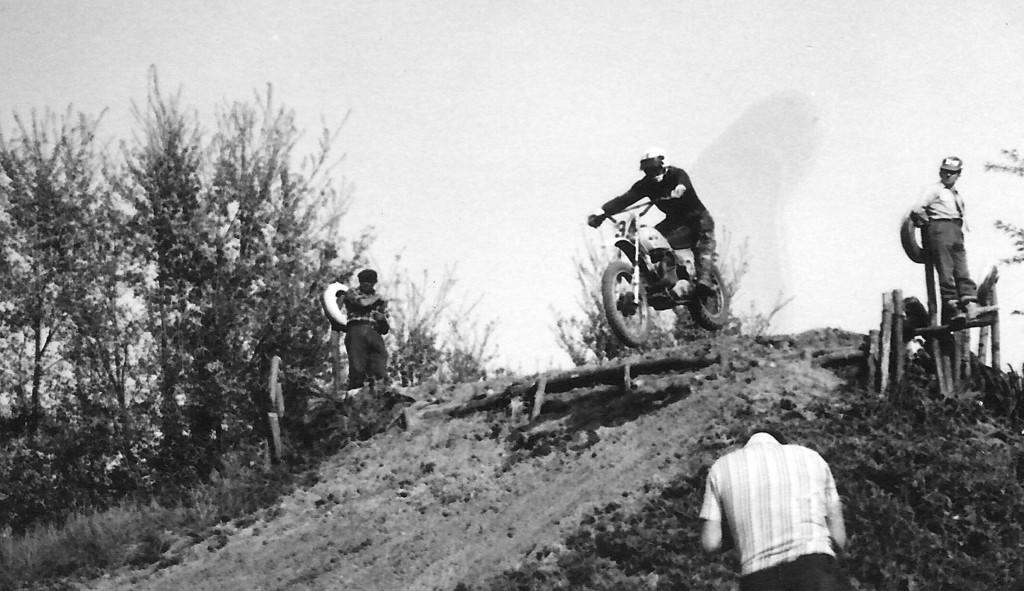Please provide a concise description of this image. This is a black and white image. In this image I can see four people among which one person is riding down a bike. I can see two people standing beside far away from him. I can see another person standing at the bottom of the image. I can see trees on the left hand side of the image. At the top of the image I can see the sky. 